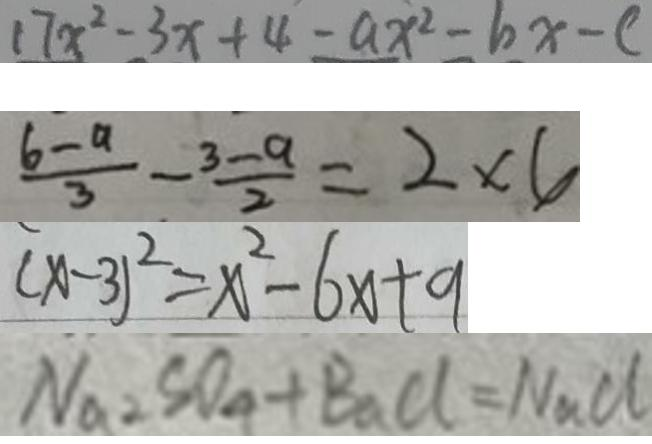<formula> <loc_0><loc_0><loc_500><loc_500>1 7 x ^ { 2 } - 3 x + 4 - a x ^ { 2 } - 6 x - c 
 \frac { 6 - a } { 3 } - \frac { 3 - a } { 2 } = 2 \times 6 
 ( x - 3 ) ^ { 2 } = x ^ { 2 } - 6 x + 9 
 N a S O _ { 4 } + B a C l = N a C l</formula> 